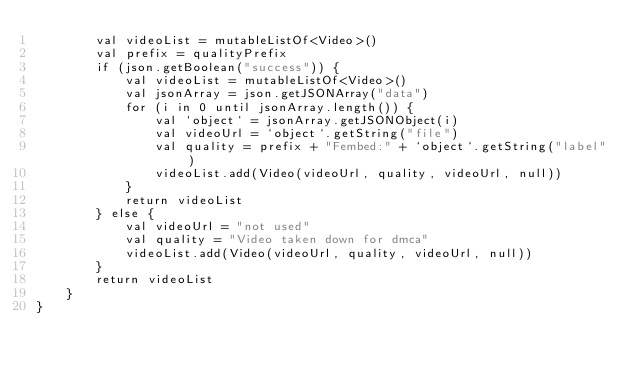<code> <loc_0><loc_0><loc_500><loc_500><_Kotlin_>        val videoList = mutableListOf<Video>()
        val prefix = qualityPrefix
        if (json.getBoolean("success")) {
            val videoList = mutableListOf<Video>()
            val jsonArray = json.getJSONArray("data")
            for (i in 0 until jsonArray.length()) {
                val `object` = jsonArray.getJSONObject(i)
                val videoUrl = `object`.getString("file")
                val quality = prefix + "Fembed:" + `object`.getString("label")
                videoList.add(Video(videoUrl, quality, videoUrl, null))
            }
            return videoList
        } else {
            val videoUrl = "not used"
            val quality = "Video taken down for dmca"
            videoList.add(Video(videoUrl, quality, videoUrl, null))
        }
        return videoList
    }
}
</code> 